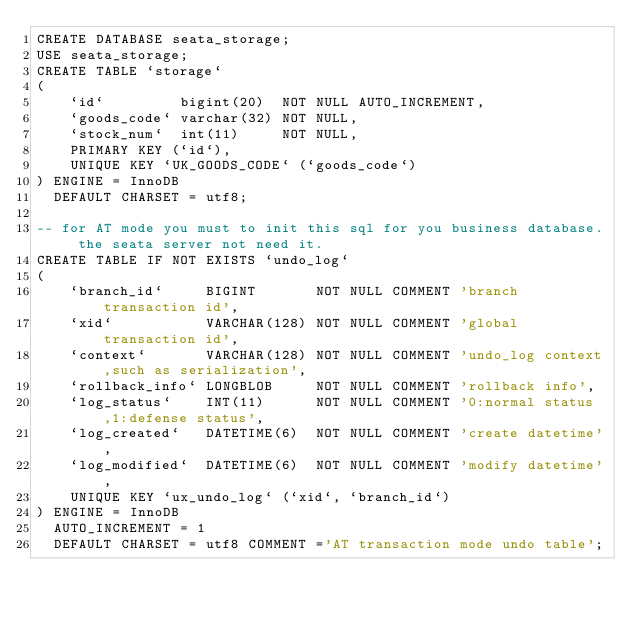Convert code to text. <code><loc_0><loc_0><loc_500><loc_500><_SQL_>CREATE DATABASE seata_storage;
USE seata_storage;
CREATE TABLE `storage`
(
    `id`         bigint(20)  NOT NULL AUTO_INCREMENT,
    `goods_code` varchar(32) NOT NULL,
    `stock_num`  int(11)     NOT NULL,
    PRIMARY KEY (`id`),
    UNIQUE KEY `UK_GOODS_CODE` (`goods_code`)
) ENGINE = InnoDB
  DEFAULT CHARSET = utf8;

-- for AT mode you must to init this sql for you business database. the seata server not need it.
CREATE TABLE IF NOT EXISTS `undo_log`
(
    `branch_id`     BIGINT       NOT NULL COMMENT 'branch transaction id',
    `xid`           VARCHAR(128) NOT NULL COMMENT 'global transaction id',
    `context`       VARCHAR(128) NOT NULL COMMENT 'undo_log context,such as serialization',
    `rollback_info` LONGBLOB     NOT NULL COMMENT 'rollback info',
    `log_status`    INT(11)      NOT NULL COMMENT '0:normal status,1:defense status',
    `log_created`   DATETIME(6)  NOT NULL COMMENT 'create datetime',
    `log_modified`  DATETIME(6)  NOT NULL COMMENT 'modify datetime',
    UNIQUE KEY `ux_undo_log` (`xid`, `branch_id`)
) ENGINE = InnoDB
  AUTO_INCREMENT = 1
  DEFAULT CHARSET = utf8 COMMENT ='AT transaction mode undo table';</code> 